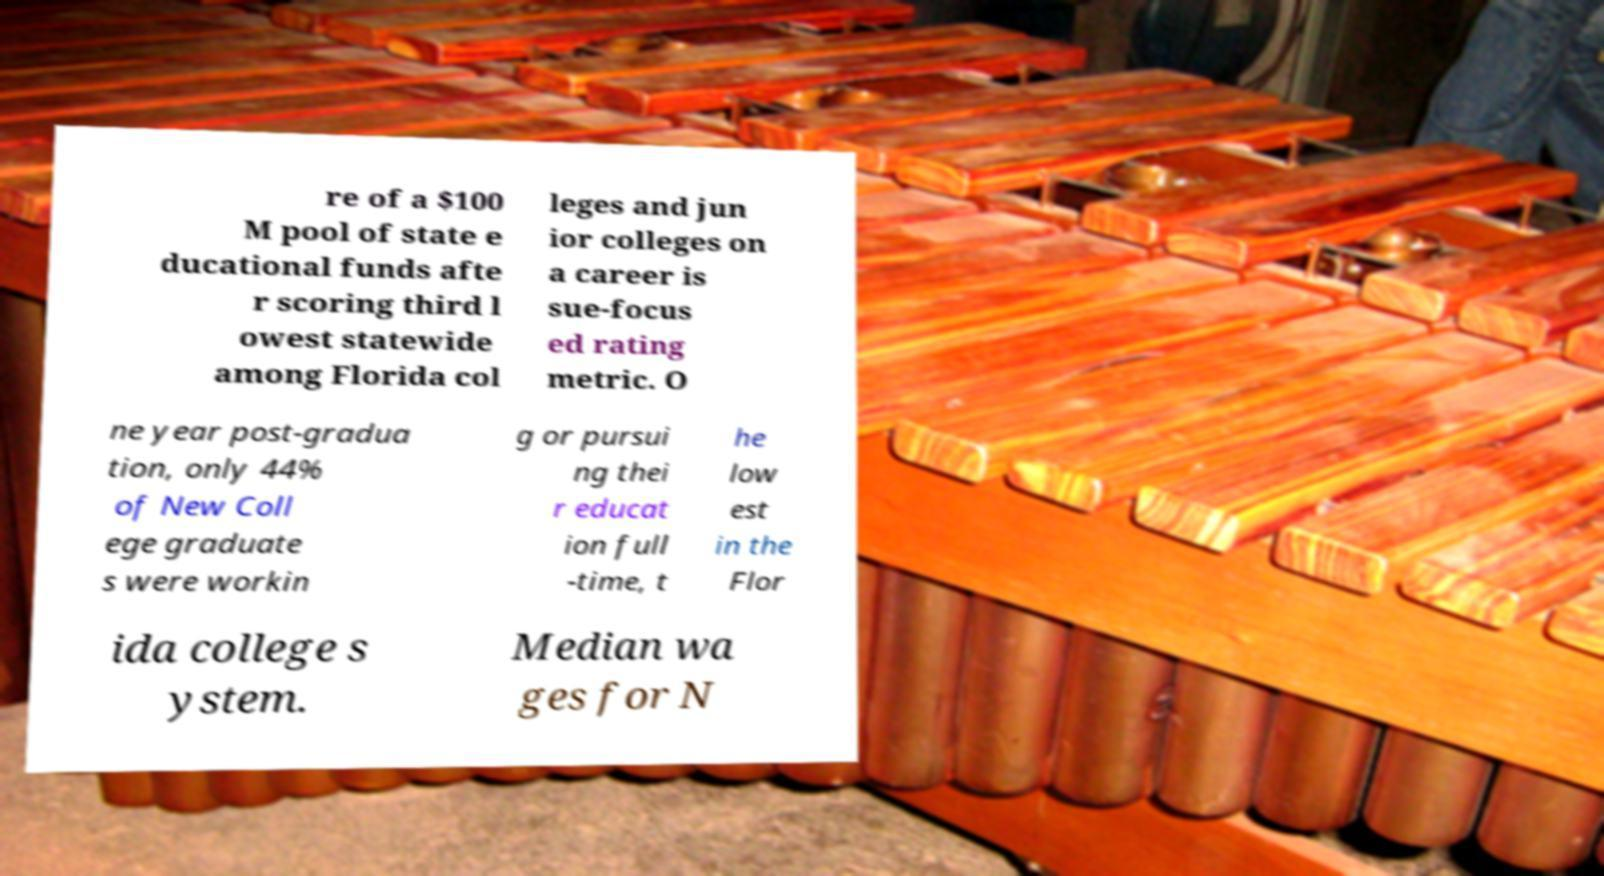Can you read and provide the text displayed in the image?This photo seems to have some interesting text. Can you extract and type it out for me? re of a $100 M pool of state e ducational funds afte r scoring third l owest statewide among Florida col leges and jun ior colleges on a career is sue-focus ed rating metric. O ne year post-gradua tion, only 44% of New Coll ege graduate s were workin g or pursui ng thei r educat ion full -time, t he low est in the Flor ida college s ystem. Median wa ges for N 